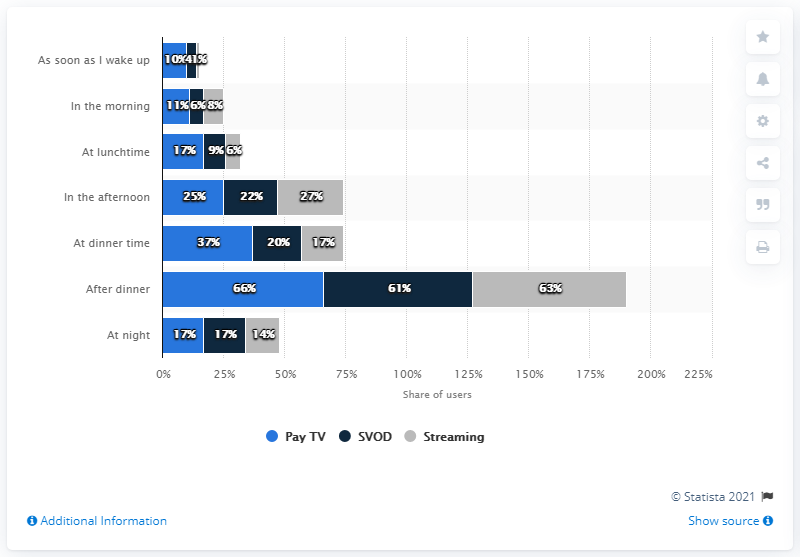Point out several critical features in this image. Watching videos during dinner time had a larger difference between Pay TV and SVOD compared to after dinner. 